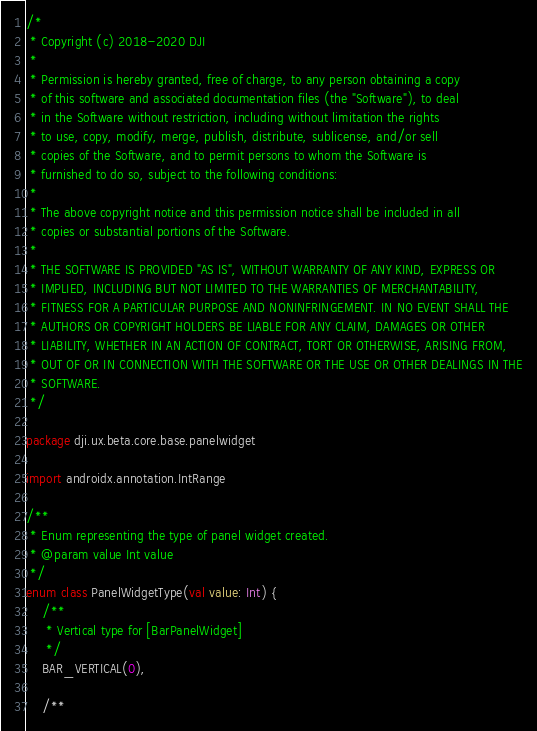Convert code to text. <code><loc_0><loc_0><loc_500><loc_500><_Kotlin_>/*
 * Copyright (c) 2018-2020 DJI
 *
 * Permission is hereby granted, free of charge, to any person obtaining a copy
 * of this software and associated documentation files (the "Software"), to deal
 * in the Software without restriction, including without limitation the rights
 * to use, copy, modify, merge, publish, distribute, sublicense, and/or sell
 * copies of the Software, and to permit persons to whom the Software is
 * furnished to do so, subject to the following conditions:
 *
 * The above copyright notice and this permission notice shall be included in all
 * copies or substantial portions of the Software.
 *
 * THE SOFTWARE IS PROVIDED "AS IS", WITHOUT WARRANTY OF ANY KIND, EXPRESS OR
 * IMPLIED, INCLUDING BUT NOT LIMITED TO THE WARRANTIES OF MERCHANTABILITY,
 * FITNESS FOR A PARTICULAR PURPOSE AND NONINFRINGEMENT. IN NO EVENT SHALL THE
 * AUTHORS OR COPYRIGHT HOLDERS BE LIABLE FOR ANY CLAIM, DAMAGES OR OTHER
 * LIABILITY, WHETHER IN AN ACTION OF CONTRACT, TORT OR OTHERWISE, ARISING FROM,
 * OUT OF OR IN CONNECTION WITH THE SOFTWARE OR THE USE OR OTHER DEALINGS IN THE
 * SOFTWARE.
 */

package dji.ux.beta.core.base.panelwidget

import androidx.annotation.IntRange

/**
 * Enum representing the type of panel widget created.
 * @param value Int value
 */
enum class PanelWidgetType(val value: Int) {
    /**
     * Vertical type for [BarPanelWidget]
     */
    BAR_VERTICAL(0),

    /**</code> 